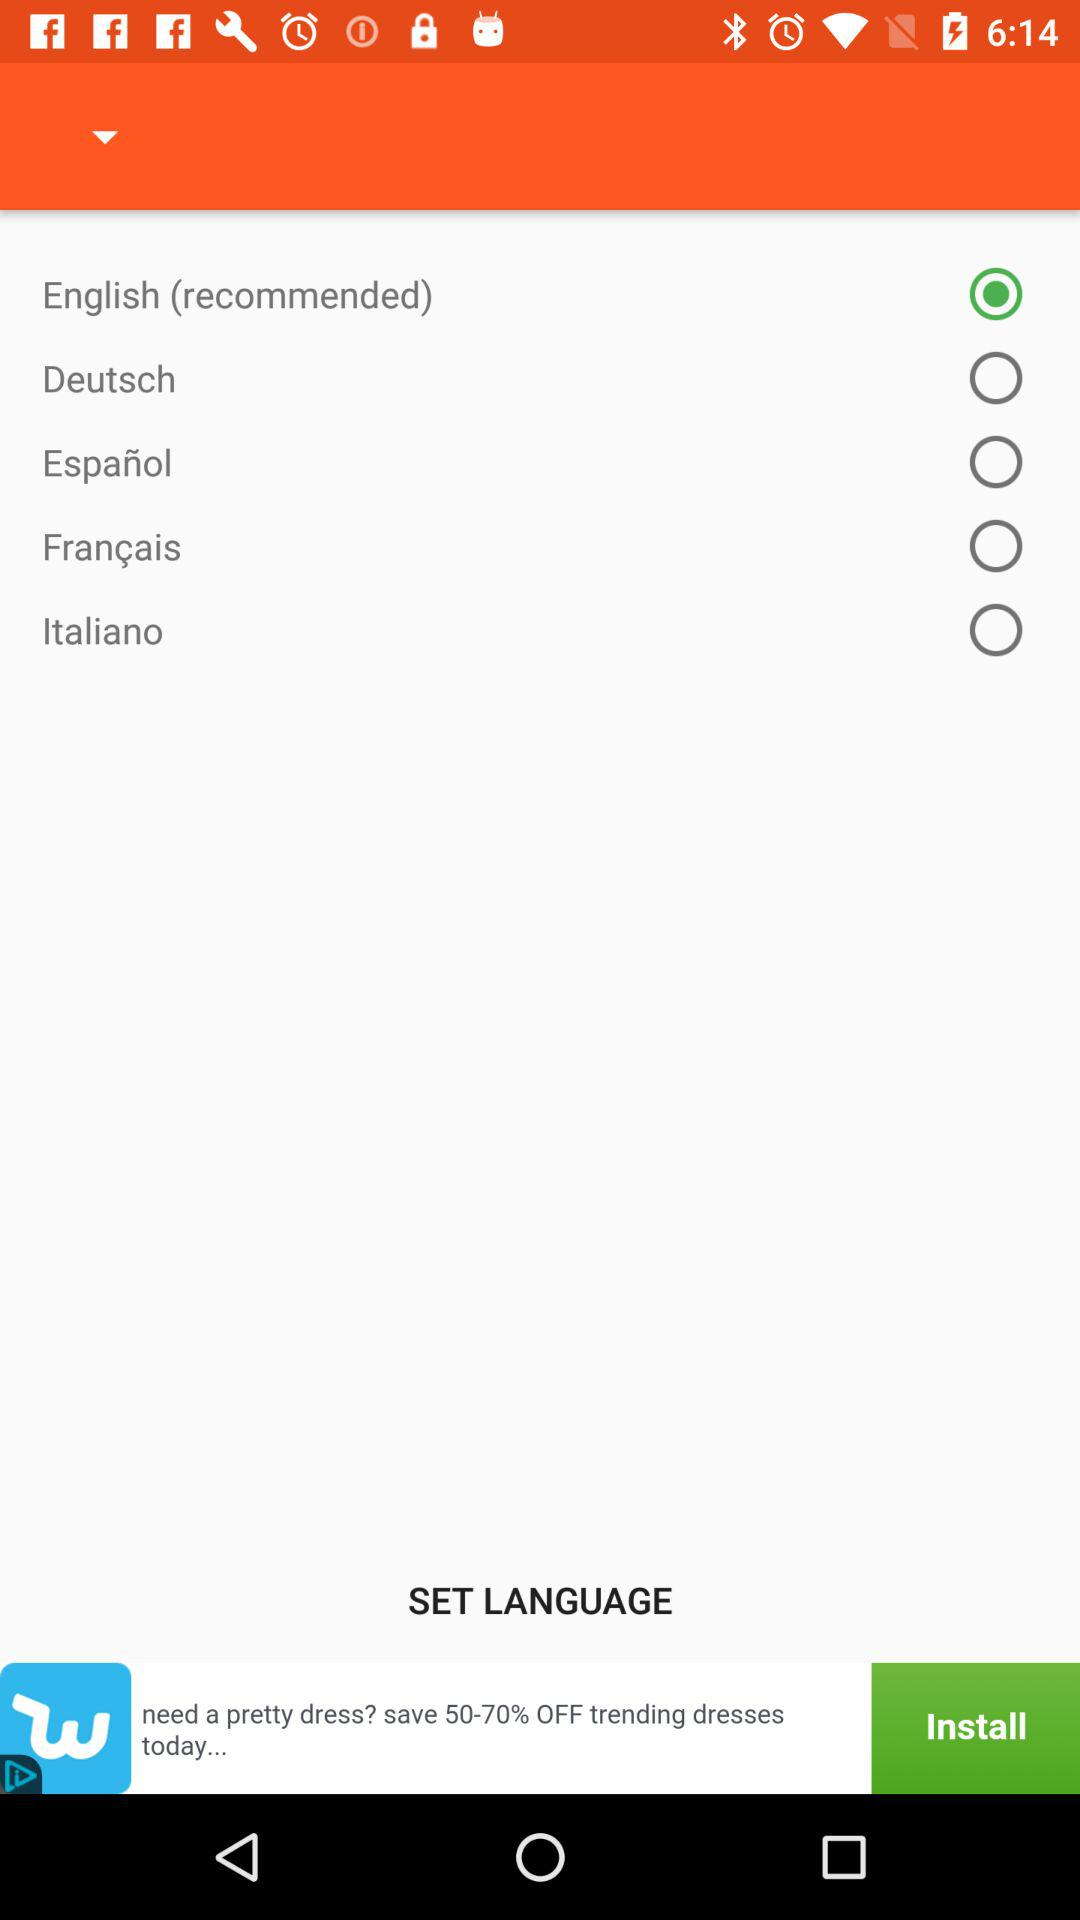Which option is selected? The selected option is "English (recommended)". 